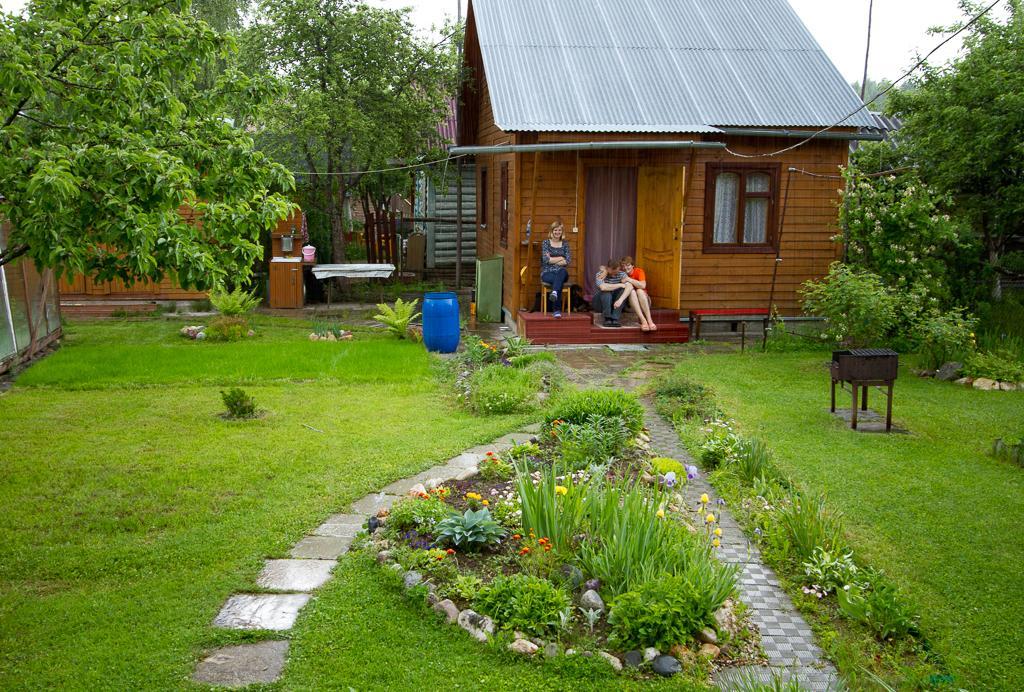In one or two sentences, can you explain what this image depicts? In this image, we can see house, window, curtains, few people, plants, trees, grass, walkways and some objects. Here we can see three people are sitting. Background we can see few houses and sky. 